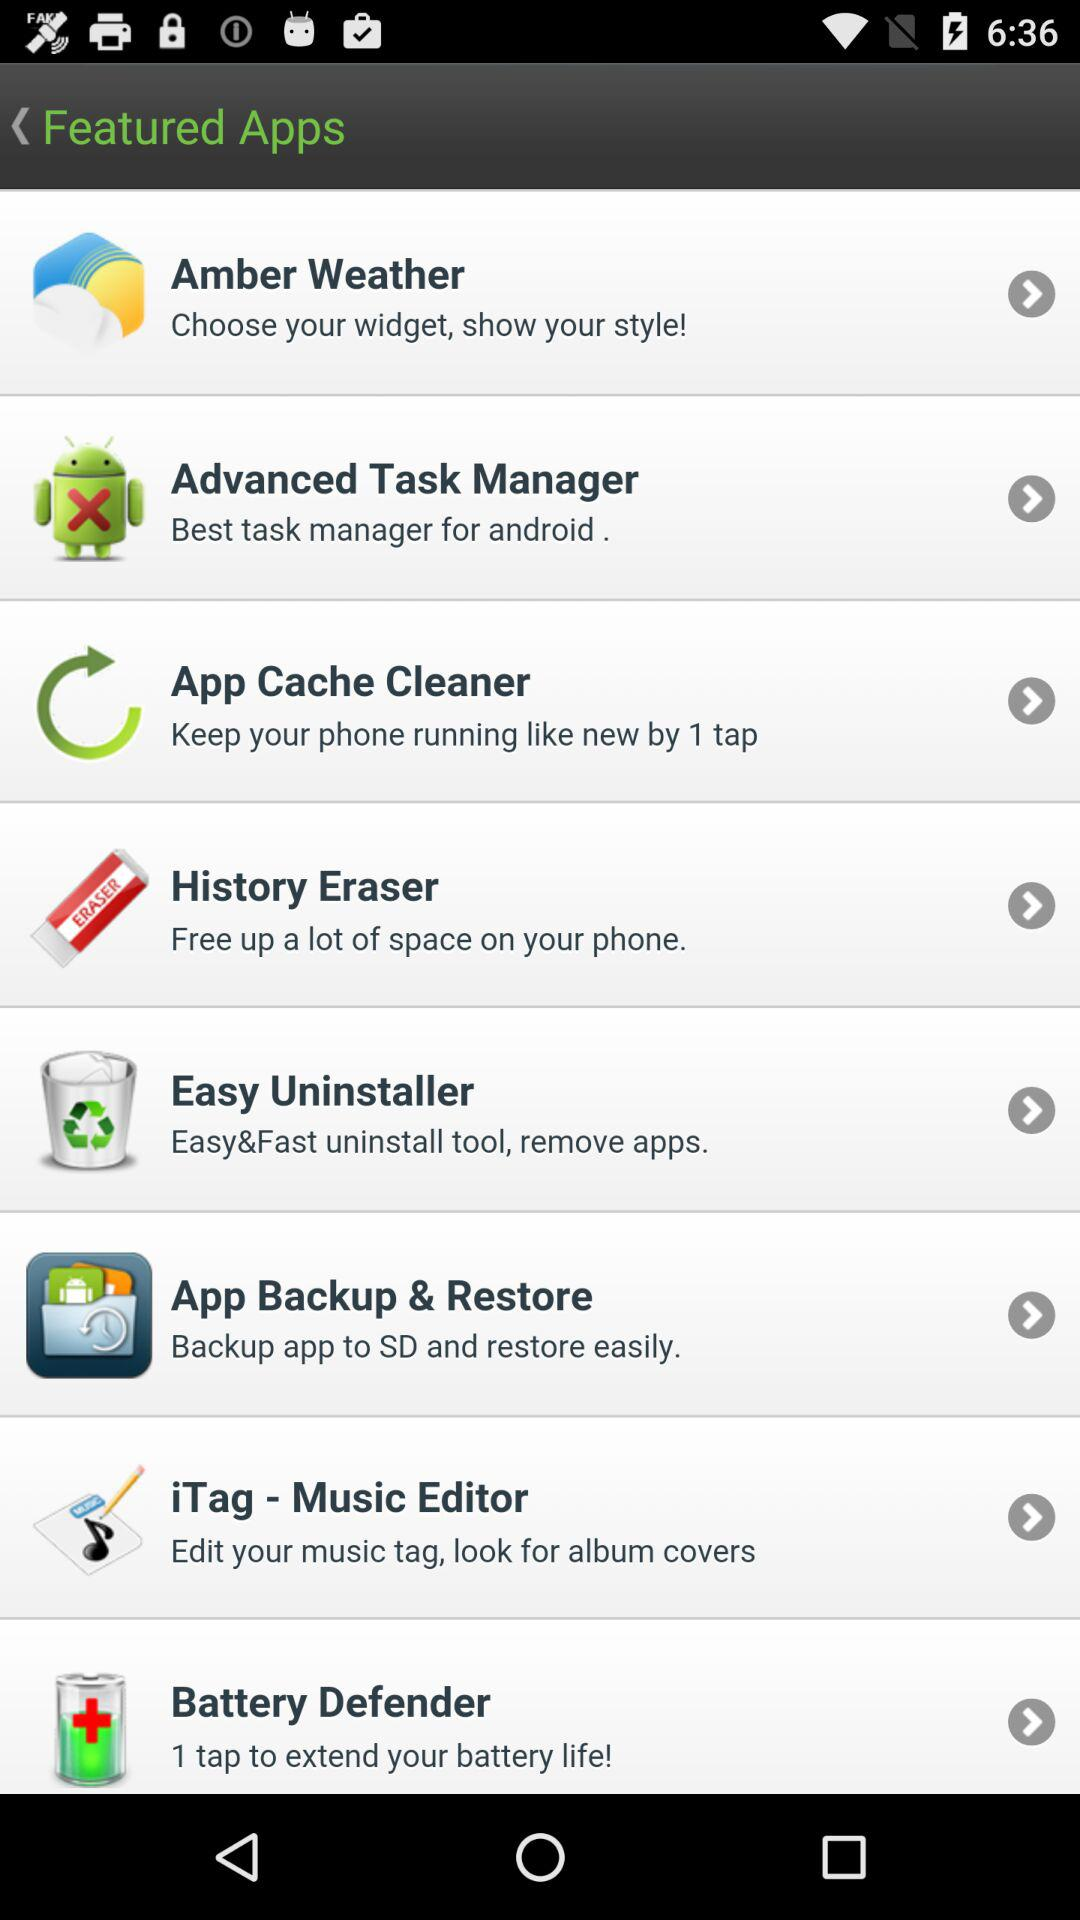What is the feature of the "App Cache Cleaner"? The feature is "Keep your phone running like by 1 tap". 